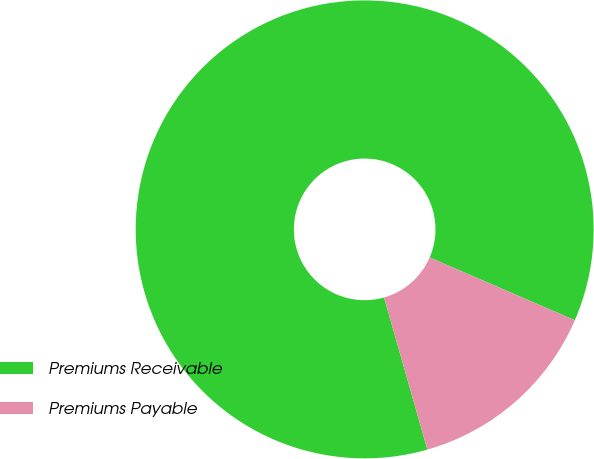Convert chart. <chart><loc_0><loc_0><loc_500><loc_500><pie_chart><fcel>Premiums Receivable<fcel>Premiums Payable<nl><fcel>85.91%<fcel>14.09%<nl></chart> 